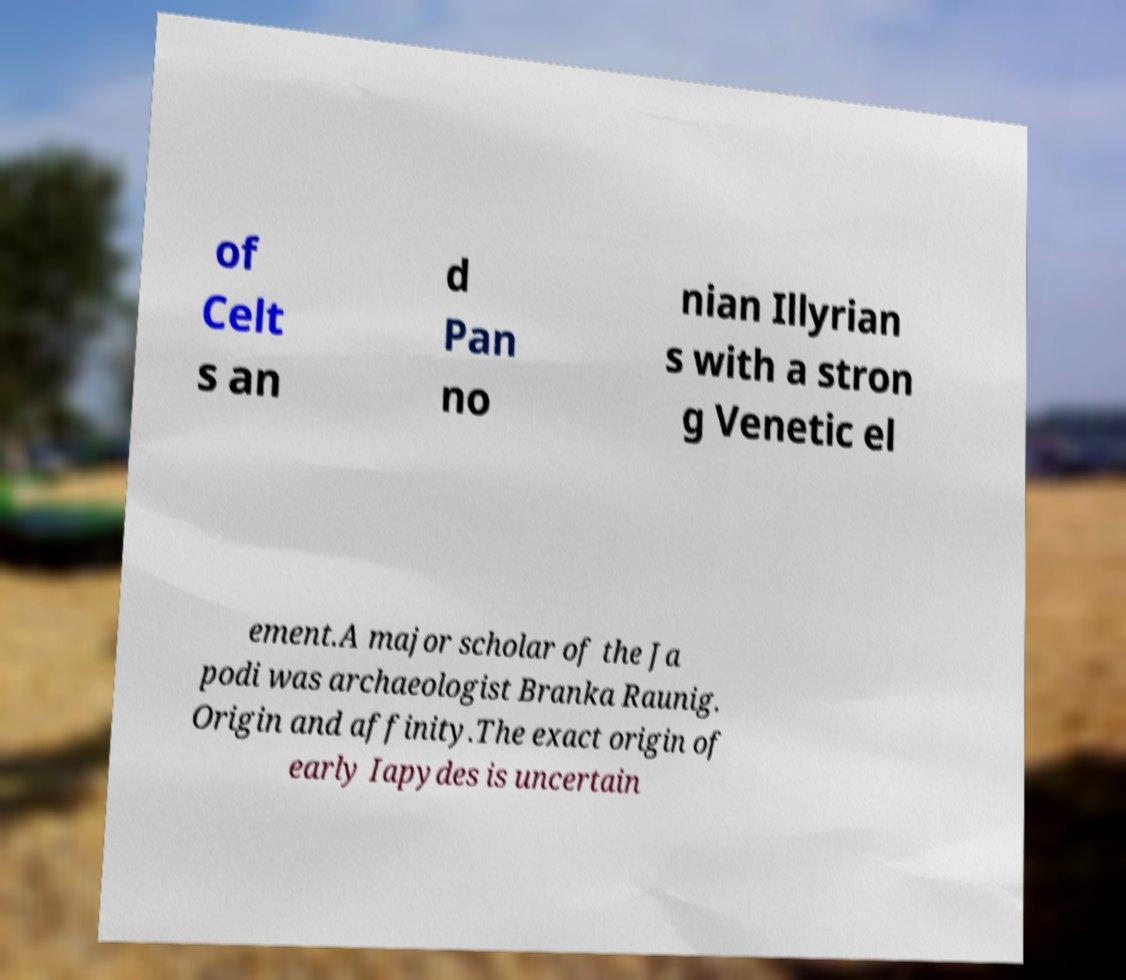What messages or text are displayed in this image? I need them in a readable, typed format. of Celt s an d Pan no nian Illyrian s with a stron g Venetic el ement.A major scholar of the Ja podi was archaeologist Branka Raunig. Origin and affinity.The exact origin of early Iapydes is uncertain 